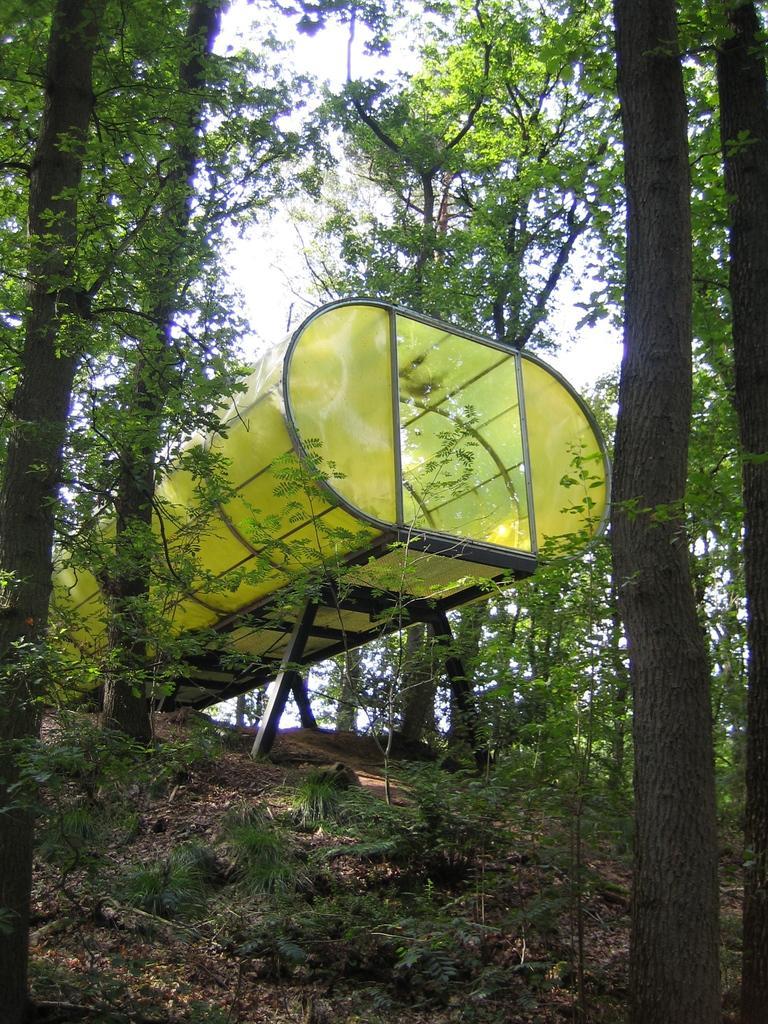In one or two sentences, can you explain what this image depicts? In this image I can see a shed in green color, background I can see trees in green color and the sky is in white color. 